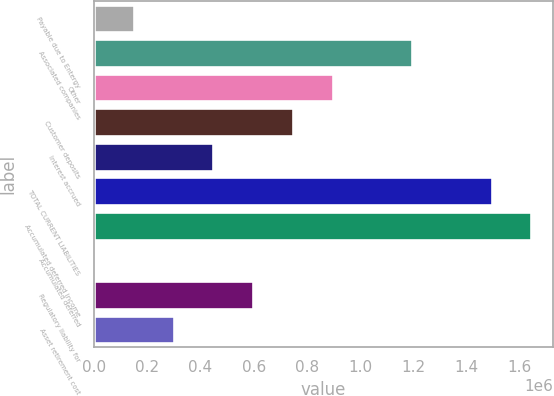<chart> <loc_0><loc_0><loc_500><loc_500><bar_chart><fcel>Payable due to Entergy<fcel>Associated companies<fcel>Other<fcel>Customer deposits<fcel>Interest accrued<fcel>TOTAL CURRENT LIABILITIES<fcel>Accumulated deferred income<fcel>Accumulated deferred<fcel>Regulatory liability for<fcel>Asset retirement cost<nl><fcel>150017<fcel>1.19578e+06<fcel>896990<fcel>747596<fcel>448806<fcel>1.49457e+06<fcel>1.64396e+06<fcel>622<fcel>598201<fcel>299411<nl></chart> 